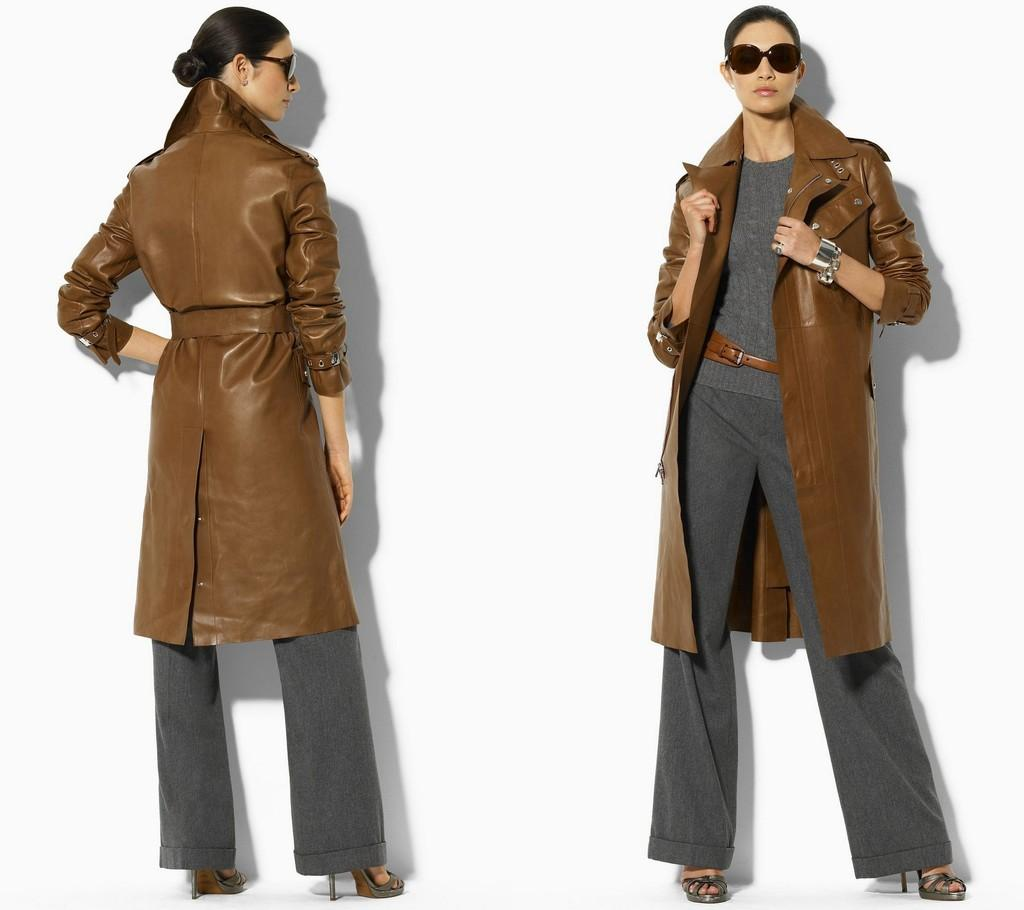How many people are in the image? There are two people in the image. What are the people doing in the image? The two people are standing on the floor. What type of clothing are the people wearing in the image? Both people are wearing jackets. What type of trains can be seen in the image? There are no trains present in the image. What color is the eye of the person on the left side of the image? There is no eye visible in the image, as it features two people standing on the floor. What type of crate is being used to store items in the image? There is no crate present in the image. 